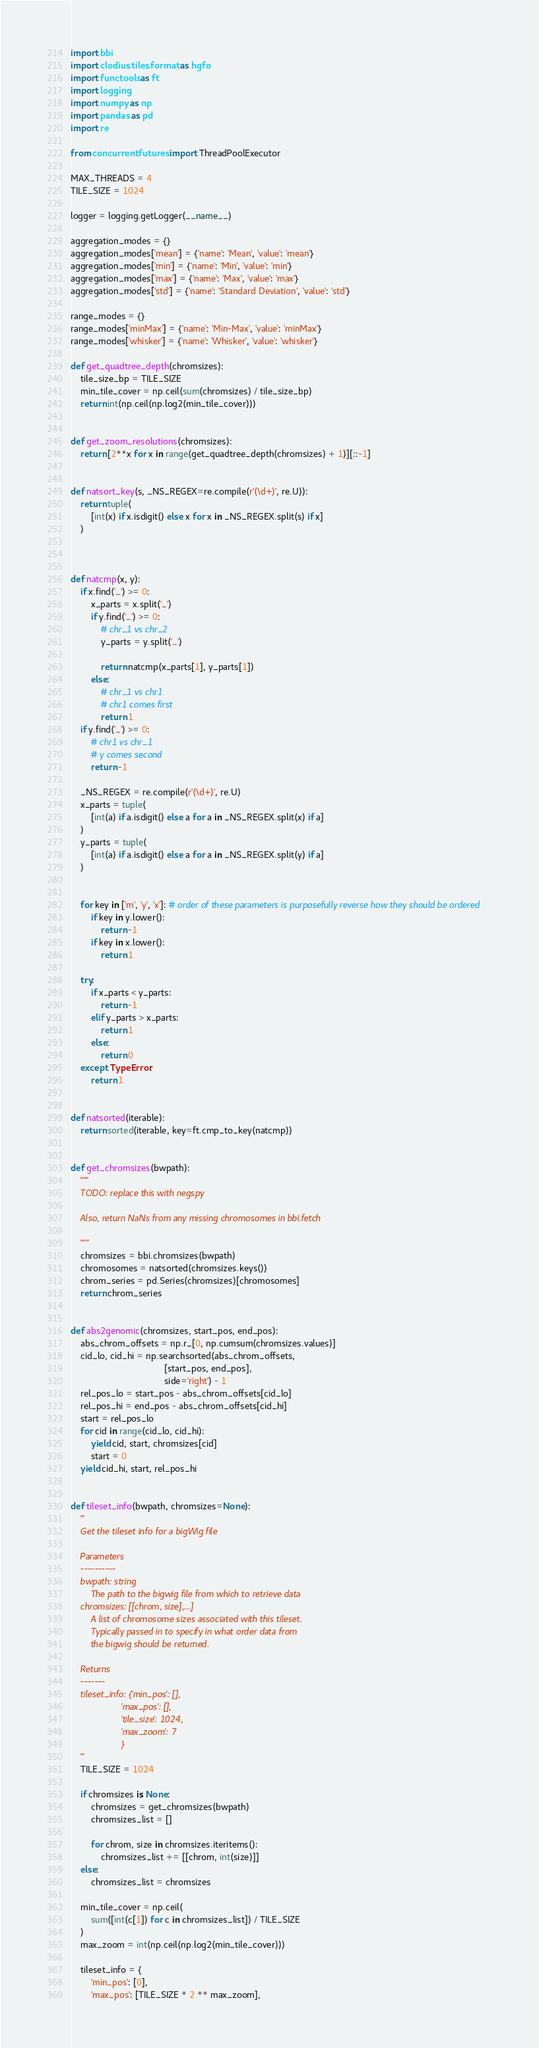Convert code to text. <code><loc_0><loc_0><loc_500><loc_500><_Python_>import bbi
import clodius.tiles.format as hgfo
import functools as ft
import logging
import numpy as np
import pandas as pd
import re

from concurrent.futures import ThreadPoolExecutor

MAX_THREADS = 4
TILE_SIZE = 1024

logger = logging.getLogger(__name__)

aggregation_modes = {}
aggregation_modes['mean'] = {'name': 'Mean', 'value': 'mean'}
aggregation_modes['min'] = {'name': 'Min', 'value': 'min'}
aggregation_modes['max'] = {'name': 'Max', 'value': 'max'}
aggregation_modes['std'] = {'name': 'Standard Deviation', 'value': 'std'}

range_modes = {}
range_modes['minMax'] = {'name': 'Min-Max', 'value': 'minMax'}
range_modes['whisker'] = {'name': 'Whisker', 'value': 'whisker'}

def get_quadtree_depth(chromsizes):
    tile_size_bp = TILE_SIZE
    min_tile_cover = np.ceil(sum(chromsizes) / tile_size_bp)
    return int(np.ceil(np.log2(min_tile_cover)))


def get_zoom_resolutions(chromsizes):
    return [2**x for x in range(get_quadtree_depth(chromsizes) + 1)][::-1]


def natsort_key(s, _NS_REGEX=re.compile(r'(\d+)', re.U)):
    return tuple(
        [int(x) if x.isdigit() else x for x in _NS_REGEX.split(s) if x]
    )



def natcmp(x, y):
    if x.find('_') >= 0:
        x_parts = x.split('_')
        if y.find('_') >= 0:
            # chr_1 vs chr_2
            y_parts = y.split('_')

            return natcmp(x_parts[1], y_parts[1])
        else:
            # chr_1 vs chr1
            # chr1 comes first
            return 1
    if y.find('_') >= 0:
        # chr1 vs chr_1
        # y comes second
        return -1

    _NS_REGEX = re.compile(r'(\d+)', re.U)
    x_parts = tuple(
        [int(a) if a.isdigit() else a for a in _NS_REGEX.split(x) if a]
    )
    y_parts = tuple(
        [int(a) if a.isdigit() else a for a in _NS_REGEX.split(y) if a]
    )


    for key in ['m', 'y', 'x']: # order of these parameters is purposefully reverse how they should be ordered
        if key in y.lower():
            return -1
        if key in x.lower():
            return 1

    try:
        if x_parts < y_parts:
            return -1
        elif y_parts > x_parts:
            return 1
        else:
            return 0
    except TypeError:
        return 1


def natsorted(iterable):
    return sorted(iterable, key=ft.cmp_to_key(natcmp))


def get_chromsizes(bwpath):
    """
    TODO: replace this with negspy

    Also, return NaNs from any missing chromosomes in bbi.fetch

    """
    chromsizes = bbi.chromsizes(bwpath)
    chromosomes = natsorted(chromsizes.keys())
    chrom_series = pd.Series(chromsizes)[chromosomes]
    return chrom_series


def abs2genomic(chromsizes, start_pos, end_pos):
    abs_chrom_offsets = np.r_[0, np.cumsum(chromsizes.values)]
    cid_lo, cid_hi = np.searchsorted(abs_chrom_offsets,
                                     [start_pos, end_pos],
                                     side='right') - 1
    rel_pos_lo = start_pos - abs_chrom_offsets[cid_lo]
    rel_pos_hi = end_pos - abs_chrom_offsets[cid_hi]
    start = rel_pos_lo
    for cid in range(cid_lo, cid_hi):
        yield cid, start, chromsizes[cid]
        start = 0
    yield cid_hi, start, rel_pos_hi


def tileset_info(bwpath, chromsizes=None):
    '''
    Get the tileset info for a bigWig file

    Parameters
    ----------
    bwpath: string
        The path to the bigwig file from which to retrieve data
    chromsizes: [[chrom, size],...]
        A list of chromosome sizes associated with this tileset.
        Typically passed in to specify in what order data from
        the bigwig should be returned.

    Returns
    -------
    tileset_info: {'min_pos': [],
                    'max_pos': [],
                    'tile_size': 1024,
                    'max_zoom': 7
                    }
    '''
    TILE_SIZE = 1024

    if chromsizes is None:
        chromsizes = get_chromsizes(bwpath)
        chromsizes_list = []

        for chrom, size in chromsizes.iteritems():
            chromsizes_list += [[chrom, int(size)]]
    else:
        chromsizes_list = chromsizes

    min_tile_cover = np.ceil(
        sum([int(c[1]) for c in chromsizes_list]) / TILE_SIZE
    )
    max_zoom = int(np.ceil(np.log2(min_tile_cover)))

    tileset_info = {
        'min_pos': [0],
        'max_pos': [TILE_SIZE * 2 ** max_zoom],</code> 